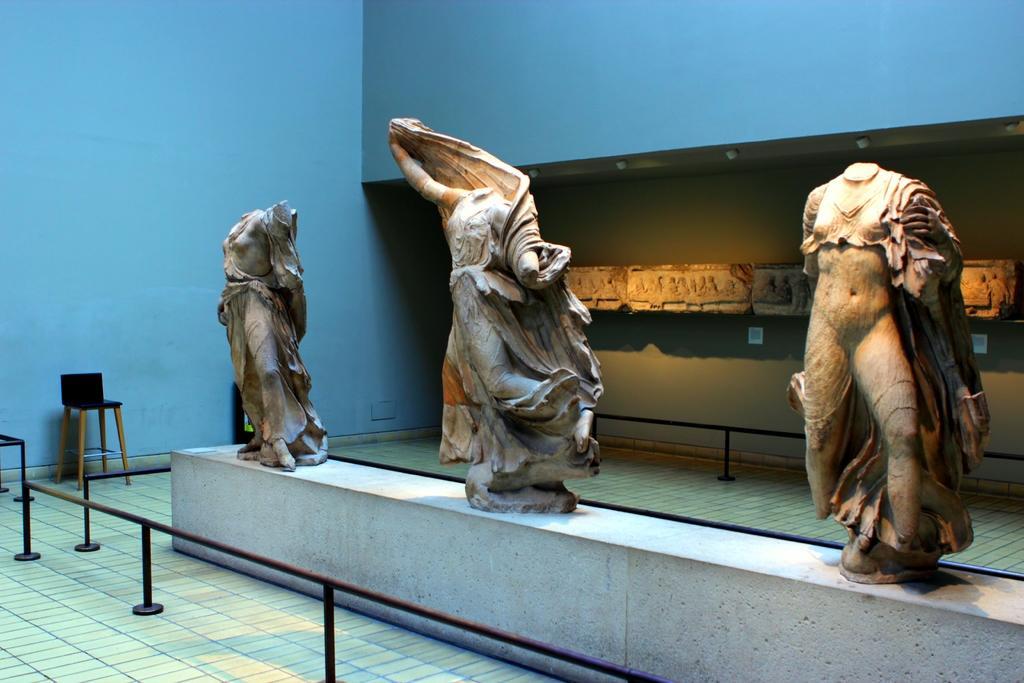Please provide a concise description of this image. In this image there are sculptures and railing, in the background there is a wall and a chair. 